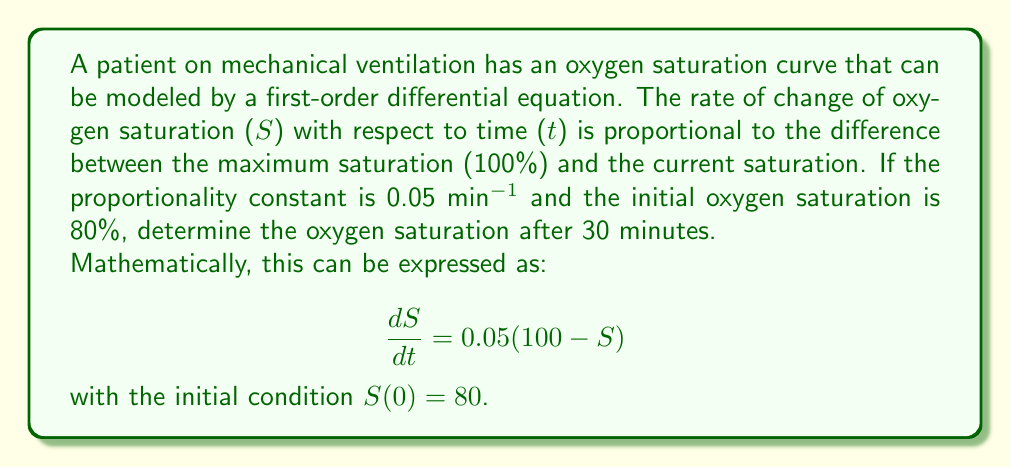Solve this math problem. To solve this first-order differential equation, we can follow these steps:

1) The general form of this equation is:
   $$\frac{dS}{dt} = k(L - S)$$
   where $k = 0.05$ and $L = 100$ (the limiting value).

2) The solution to this type of equation is:
   $$S(t) = L - (L - S_0)e^{-kt}$$
   where $S_0$ is the initial value of $S$.

3) Substituting our known values:
   $$S(t) = 100 - (100 - 80)e^{-0.05t}$$
   $$S(t) = 100 - 20e^{-0.05t}$$

4) To find the oxygen saturation after 30 minutes, we substitute $t = 30$:
   $$S(30) = 100 - 20e^{-0.05(30)}$$
   $$S(30) = 100 - 20e^{-1.5}$$

5) Calculate $e^{-1.5} \approx 0.2231$

6) Therefore:
   $$S(30) = 100 - 20(0.2231) = 100 - 4.462 = 95.538$$

The oxygen saturation after 30 minutes is approximately 95.54%.
Answer: $S(30) \approx 95.54\%$ 